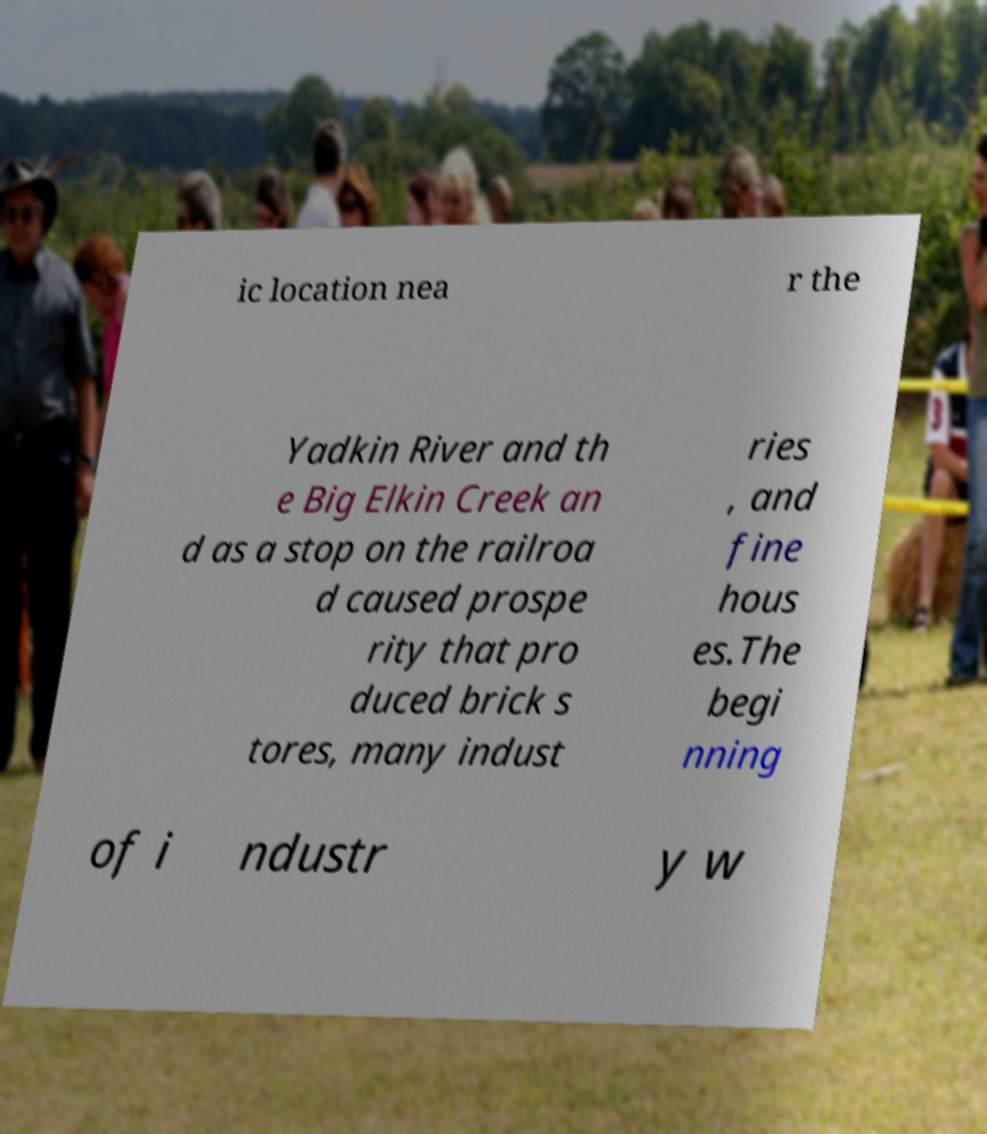Please read and relay the text visible in this image. What does it say? ic location nea r the Yadkin River and th e Big Elkin Creek an d as a stop on the railroa d caused prospe rity that pro duced brick s tores, many indust ries , and fine hous es.The begi nning of i ndustr y w 